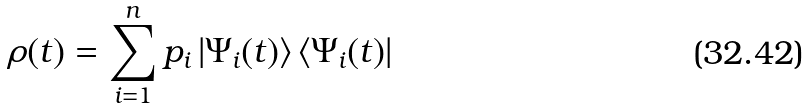<formula> <loc_0><loc_0><loc_500><loc_500>\rho ( t ) = \sum _ { i = 1 } ^ { n } p _ { i } \left | \Psi _ { i } ( t ) \right \rangle \left \langle \Psi _ { i } ( t ) \right |</formula> 